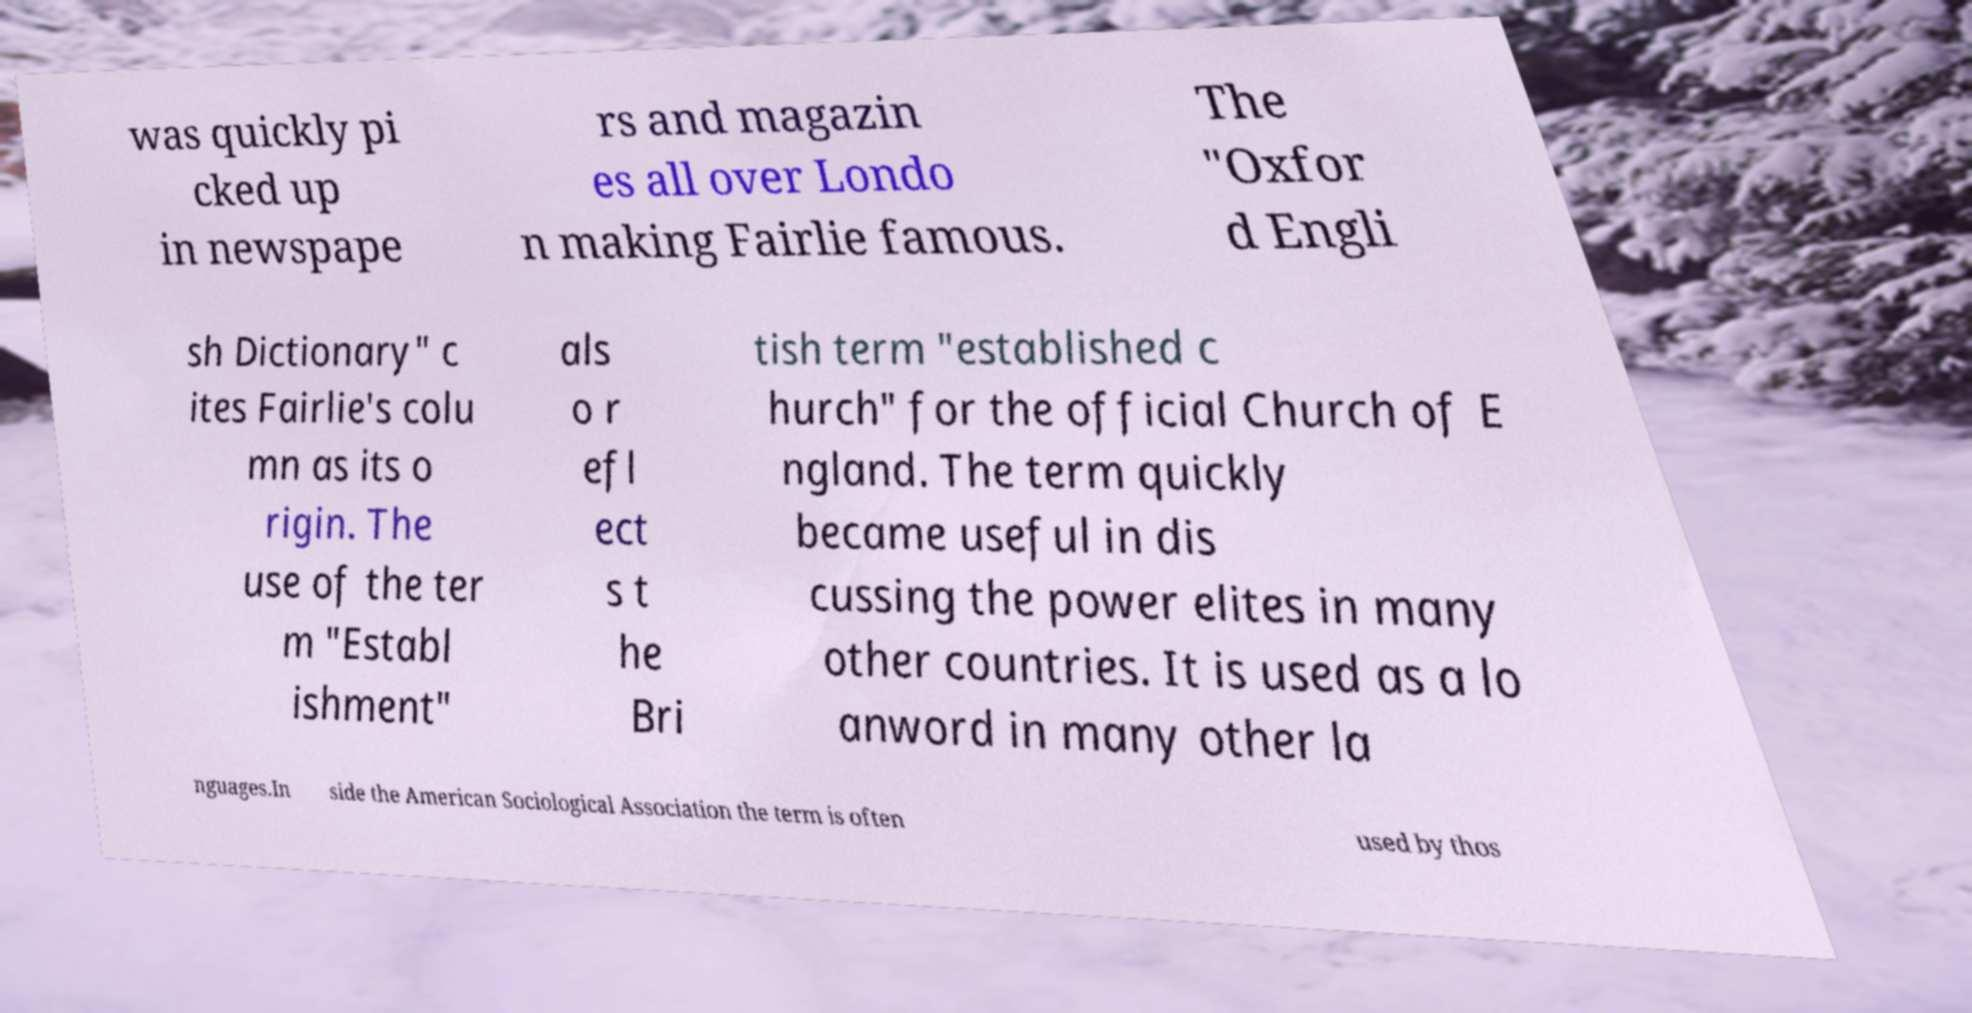Please read and relay the text visible in this image. What does it say? was quickly pi cked up in newspape rs and magazin es all over Londo n making Fairlie famous. The "Oxfor d Engli sh Dictionary" c ites Fairlie's colu mn as its o rigin. The use of the ter m "Establ ishment" als o r efl ect s t he Bri tish term "established c hurch" for the official Church of E ngland. The term quickly became useful in dis cussing the power elites in many other countries. It is used as a lo anword in many other la nguages.In side the American Sociological Association the term is often used by thos 